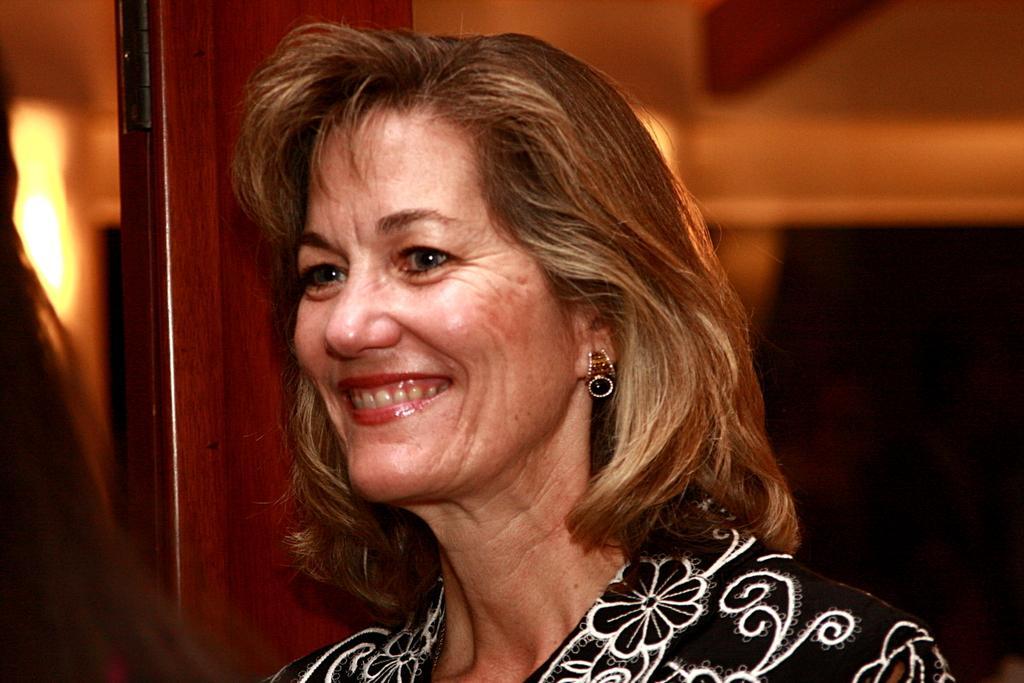Could you give a brief overview of what you see in this image? As we can see in the image in the front there is a woman wearing black color dress. In the background there is a wall and light. 